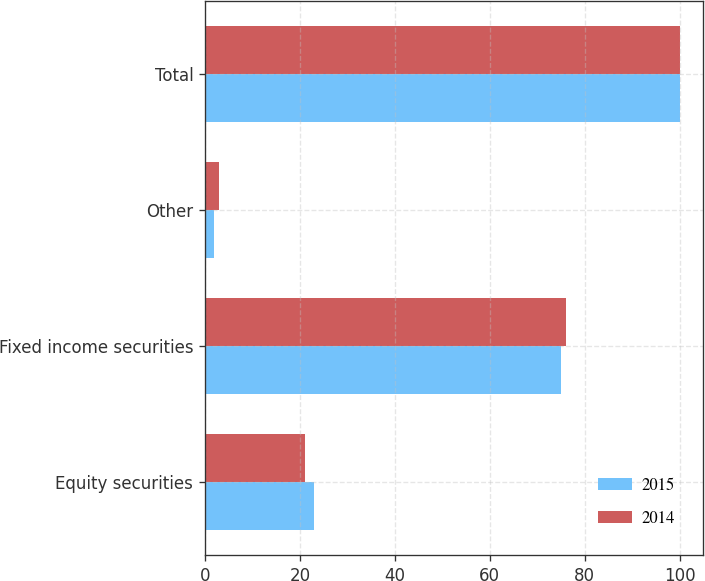<chart> <loc_0><loc_0><loc_500><loc_500><stacked_bar_chart><ecel><fcel>Equity securities<fcel>Fixed income securities<fcel>Other<fcel>Total<nl><fcel>2015<fcel>23<fcel>75<fcel>2<fcel>100<nl><fcel>2014<fcel>21<fcel>76<fcel>3<fcel>100<nl></chart> 